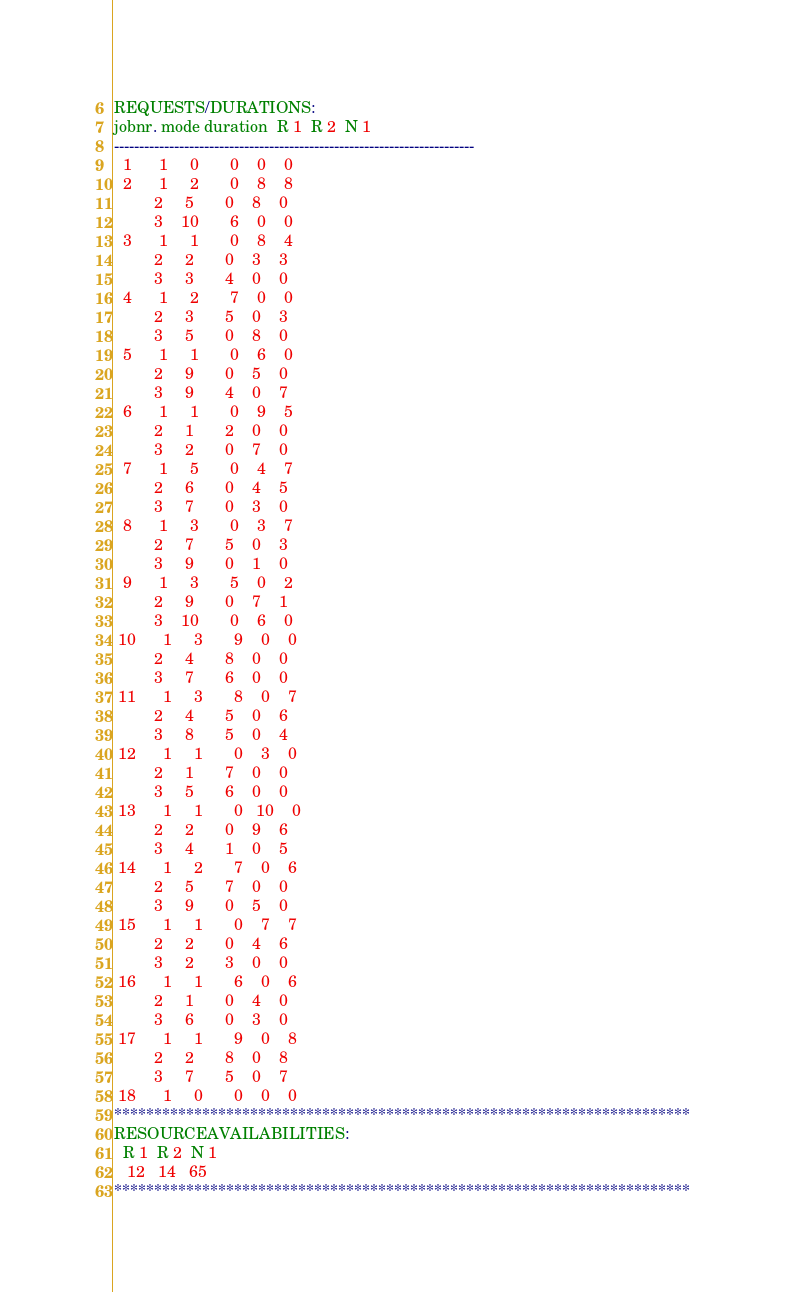<code> <loc_0><loc_0><loc_500><loc_500><_ObjectiveC_>REQUESTS/DURATIONS:
jobnr. mode duration  R 1  R 2  N 1
------------------------------------------------------------------------
  1      1     0       0    0    0
  2      1     2       0    8    8
         2     5       0    8    0
         3    10       6    0    0
  3      1     1       0    8    4
         2     2       0    3    3
         3     3       4    0    0
  4      1     2       7    0    0
         2     3       5    0    3
         3     5       0    8    0
  5      1     1       0    6    0
         2     9       0    5    0
         3     9       4    0    7
  6      1     1       0    9    5
         2     1       2    0    0
         3     2       0    7    0
  7      1     5       0    4    7
         2     6       0    4    5
         3     7       0    3    0
  8      1     3       0    3    7
         2     7       5    0    3
         3     9       0    1    0
  9      1     3       5    0    2
         2     9       0    7    1
         3    10       0    6    0
 10      1     3       9    0    0
         2     4       8    0    0
         3     7       6    0    0
 11      1     3       8    0    7
         2     4       5    0    6
         3     8       5    0    4
 12      1     1       0    3    0
         2     1       7    0    0
         3     5       6    0    0
 13      1     1       0   10    0
         2     2       0    9    6
         3     4       1    0    5
 14      1     2       7    0    6
         2     5       7    0    0
         3     9       0    5    0
 15      1     1       0    7    7
         2     2       0    4    6
         3     2       3    0    0
 16      1     1       6    0    6
         2     1       0    4    0
         3     6       0    3    0
 17      1     1       9    0    8
         2     2       8    0    8
         3     7       5    0    7
 18      1     0       0    0    0
************************************************************************
RESOURCEAVAILABILITIES:
  R 1  R 2  N 1
   12   14   65
************************************************************************
</code> 